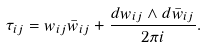Convert formula to latex. <formula><loc_0><loc_0><loc_500><loc_500>\tau _ { i j } = w _ { i j } \bar { w } _ { i j } + \frac { d w _ { i j } \wedge d \bar { w } _ { i j } } { 2 \pi i } .</formula> 